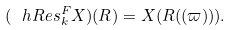Convert formula to latex. <formula><loc_0><loc_0><loc_500><loc_500>( \ h R e s ^ { F } _ { k } X ) ( R ) = X ( R ( ( \varpi ) ) ) .</formula> 